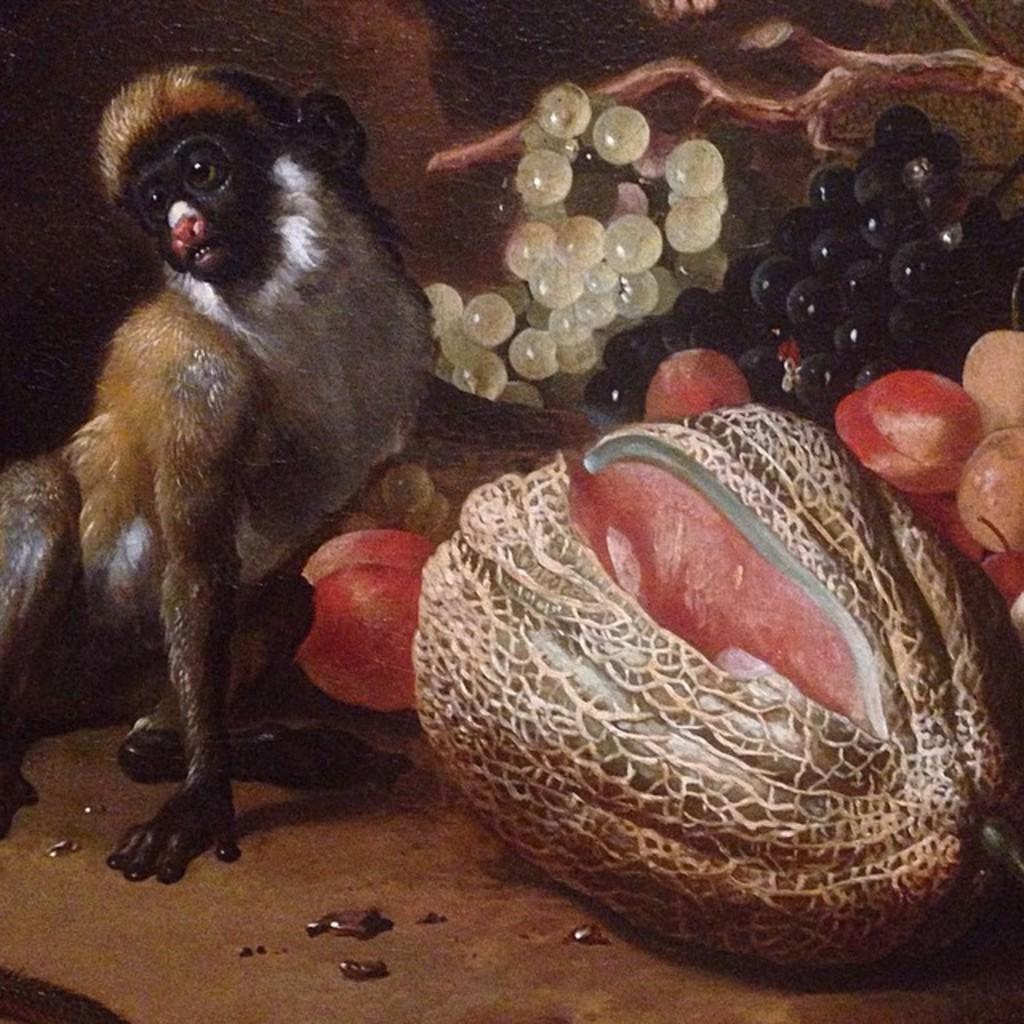What animal is on the left side of the image? There is a monkey on the left side of the image. What types of fruits can be seen in the image? The image includes grapes and papaya. What is the surface at the bottom of the image? The image has a floor at the bottom. How many gallons of water are being carried by the monkey in the image? There is no water or container visible in the image, so it is impossible to determine the amount of water being carried by the monkey. 